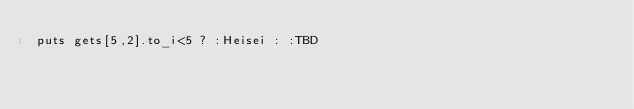Convert code to text. <code><loc_0><loc_0><loc_500><loc_500><_Ruby_>puts gets[5,2].to_i<5 ? :Heisei : :TBD
</code> 